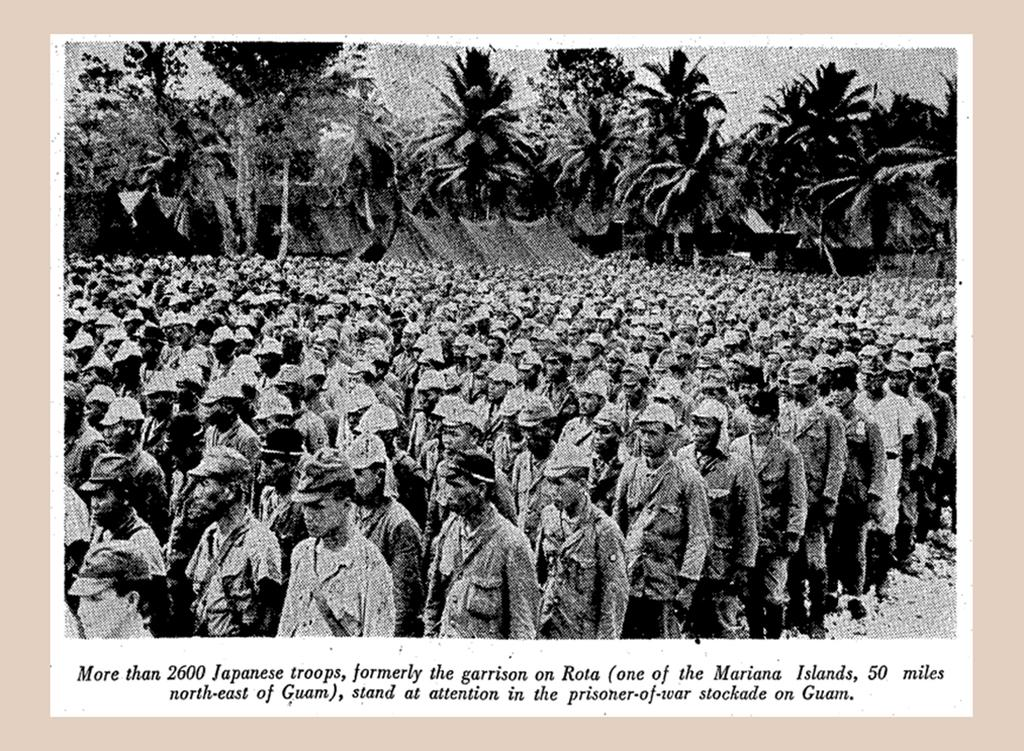Provide a one-sentence caption for the provided image. A caption under an old photograph is about Japanese troops in a prison yard on Guam. 